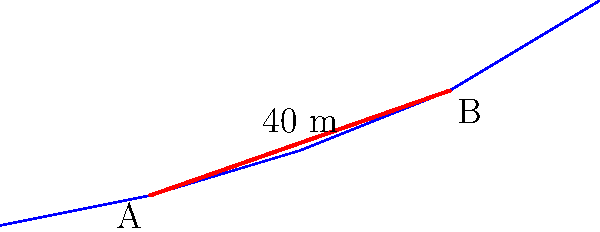As part of organizing a charity event, you're planning to construct a temporary motorcycle exhibition hall. The building's foundation needs to be excavated along a sloping terrain. The building footprint is represented by the red line AB, which is 40 meters long. If the foundation depth needs to be 2 meters below the ground level along the entire length, calculate the volume of soil to be excavated in cubic meters. Assume the width of the foundation is constant at 15 meters. To calculate the volume of soil to be excavated, we need to follow these steps:

1. Determine the average depth of excavation:
   - At point A: 2 meters below ground level
   - At point B: 2 meters below ground level
   - Average depth = $(2 + 2) / 2 = 2$ meters

2. Calculate the area of the foundation:
   - Length = 40 meters
   - Width = 15 meters
   - Area = $40 \times 15 = 600$ square meters

3. Calculate the volume of excavation:
   - Volume = Area × Average depth
   - Volume = $600 \text{ m}^2 \times 2 \text{ m} = 1200 \text{ m}^3$

Therefore, the volume of soil to be excavated is 1200 cubic meters.

Note: This calculation assumes a simplified model where the ground slope is approximated as a flat surface between points A and B. In reality, a more precise calculation would involve integrating the volume under the actual ground profile.
Answer: 1200 m³ 